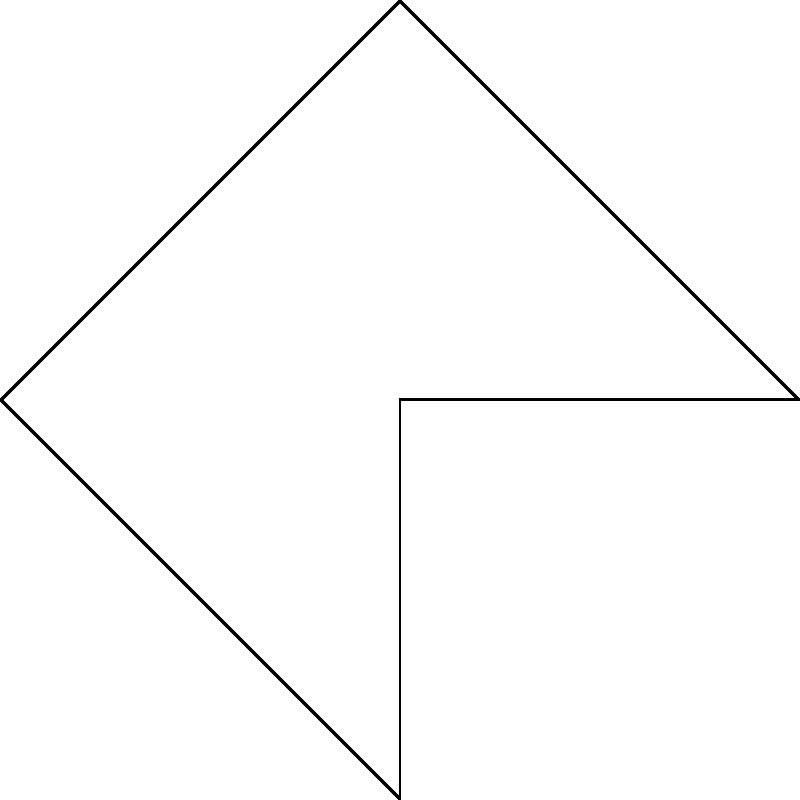A differential drive mobile robot has two wheels, each with a radius of 10 cm. The distance between the wheels is 40 cm. If the left wheel rotates at 2 rad/s and the right wheel rotates at 3 rad/s, what is the robot's velocity vector $(v_x, v_y)$ in cm/s? Let's approach this step-by-step:

1) First, we need to calculate the linear velocities of each wheel:
   $v_1 = \omega_1 r = 2 \text{ rad/s} \times 10 \text{ cm} = 20 \text{ cm/s}$
   $v_2 = \omega_2 r = 3 \text{ rad/s} \times 10 \text{ cm} = 30 \text{ cm/s}$

2) The robot's forward velocity is the average of the two wheel velocities:
   $v_f = \frac{v_1 + v_2}{2} = \frac{20 + 30}{2} = 25 \text{ cm/s}$

3) The robot's angular velocity can be calculated as:
   $\omega = \frac{v_2 - v_1}{L} = \frac{30 - 20}{40} = 0.25 \text{ rad/s}$
   where $L$ is the distance between the wheels.

4) For a differential drive robot, the velocity vector is always perpendicular to the axis connecting the wheels. Therefore, if we consider the robot's initial orientation as along the x-axis, the velocity vector will be:

   $v_x = v_f \cos(\omega t) = 25 \cos(0.25t)$
   $v_y = v_f \sin(\omega t) = 25 \sin(0.25t)$

5) At $t=0$ (initial moment), this simplifies to:
   $v_x = 25 \text{ cm/s}$
   $v_y = 0 \text{ cm/s}$

Therefore, the initial velocity vector is $(25, 0)$ cm/s.
Answer: $(25, 0)$ cm/s 